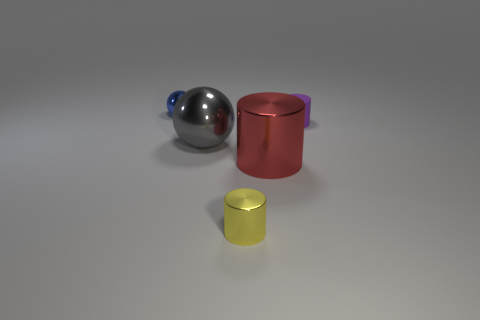Which objects in the image are reflective, and can you describe their shapes? The sphere and the large cylinder exhibit reflective surfaces. The sphere has a smooth, round shape, indicating that it can reflect its surroundings uniformly, while the large cylinder, being reflective, displays a curved side surface and two flat circular ends. The reflective qualities suggest they are likely made of a metallic material. What do the reflections on the objects say about the environment they are in? The reflections on the objects show soft diffused lighting and the absence of any distinct features, suggesting they are placed in an environment with even, nondirectional light, likely intended to prevent any particular detail from overpowering the scene. This kind of setting is typical for studio or rendered images, where the focus is on the objects themselves rather than their surroundings. 